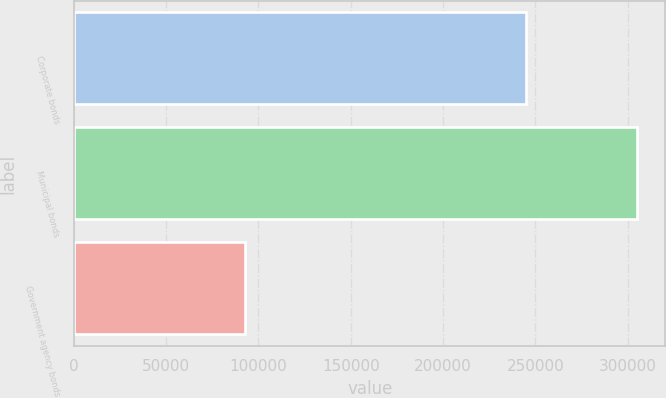Convert chart. <chart><loc_0><loc_0><loc_500><loc_500><bar_chart><fcel>Corporate bonds<fcel>Municipal bonds<fcel>Government agency bonds<nl><fcel>244709<fcel>305268<fcel>92734<nl></chart> 